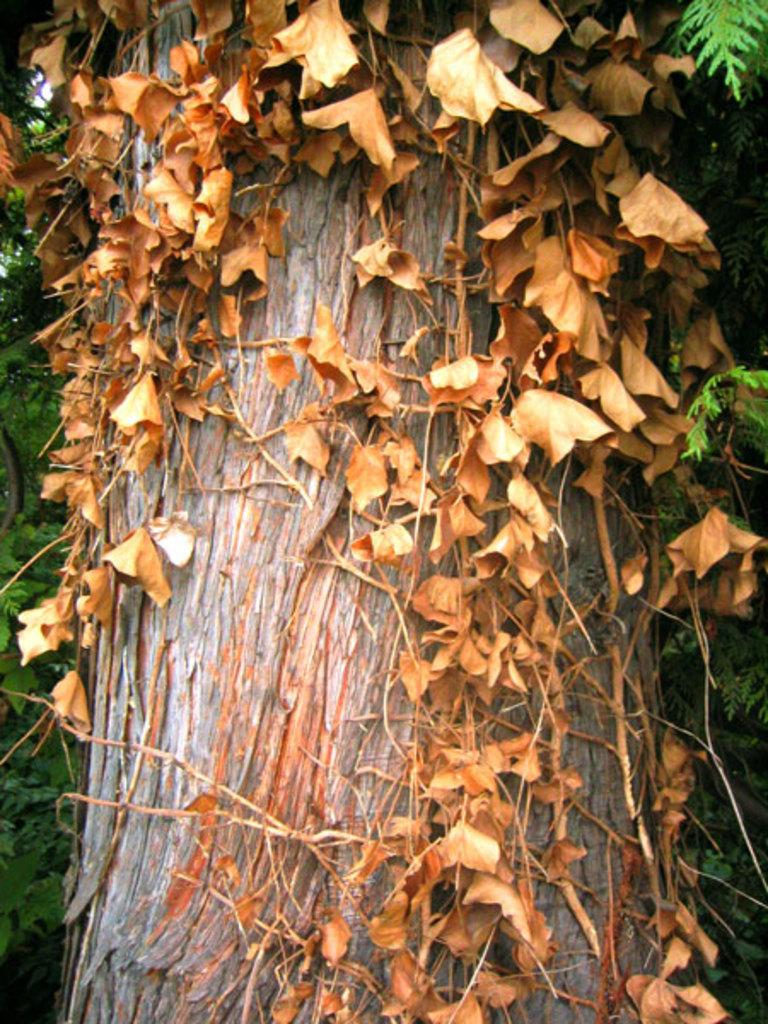Where was the image taken? The image was taken outdoors. What can be seen in the background of the image? There are plants and trees with green leaves in the background of the image. Can you describe the tree in the middle of the image? The tree has a branch and stems in the middle of the image, and it has dry leaves. What type of glue is being used to hold the playground equipment together in the image? There is no playground equipment present in the image, so it is not possible to determine what type of glue might be used. 